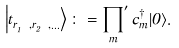<formula> <loc_0><loc_0><loc_500><loc_500>\left | t ^ { \ } _ { r ^ { \ } _ { 1 } , r ^ { \ } _ { 2 } , \dots } \right \rangle \colon = { \prod _ { m } } ^ { \prime } \, \hat { c } ^ { \dag } _ { m } | 0 \rangle .</formula> 